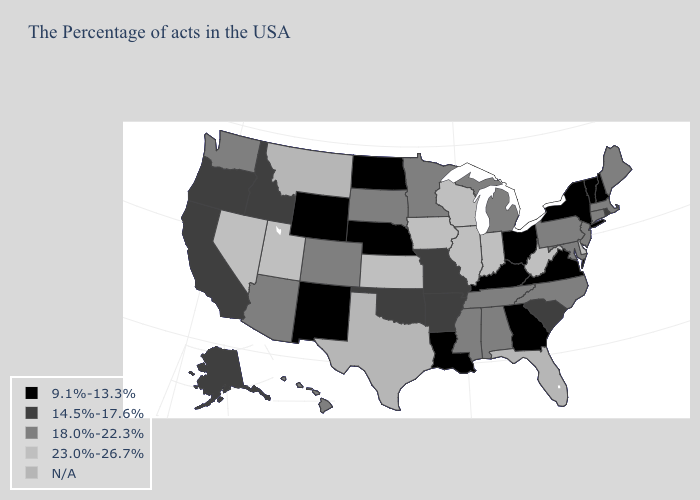What is the value of Louisiana?
Be succinct. 9.1%-13.3%. Does the first symbol in the legend represent the smallest category?
Be succinct. Yes. Name the states that have a value in the range 9.1%-13.3%?
Concise answer only. New Hampshire, Vermont, New York, Virginia, Ohio, Georgia, Kentucky, Louisiana, Nebraska, North Dakota, Wyoming, New Mexico. What is the lowest value in the West?
Concise answer only. 9.1%-13.3%. Which states hav the highest value in the Northeast?
Concise answer only. Maine, Massachusetts, Connecticut, New Jersey, Pennsylvania. How many symbols are there in the legend?
Answer briefly. 5. What is the value of Illinois?
Answer briefly. 23.0%-26.7%. What is the value of Rhode Island?
Short answer required. 14.5%-17.6%. Does Iowa have the highest value in the MidWest?
Write a very short answer. Yes. What is the value of Minnesota?
Give a very brief answer. 18.0%-22.3%. Does Virginia have the lowest value in the USA?
Short answer required. Yes. What is the value of Kansas?
Concise answer only. 23.0%-26.7%. Does New Mexico have the lowest value in the West?
Give a very brief answer. Yes. What is the value of Alabama?
Keep it brief. 18.0%-22.3%. Does Mississippi have the highest value in the USA?
Short answer required. No. 